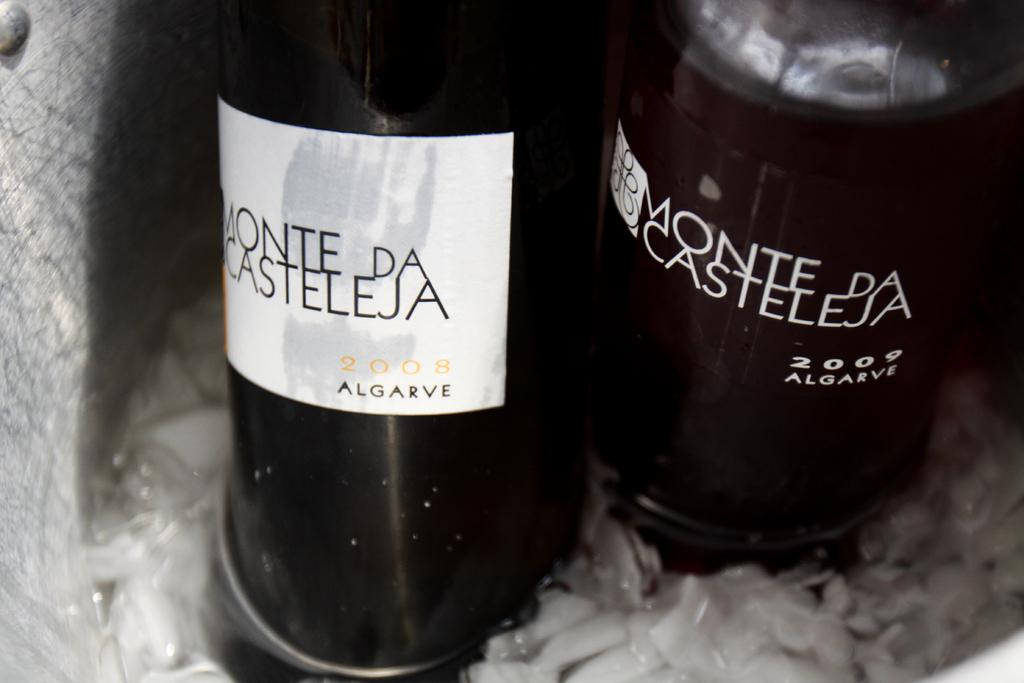<image>
Describe the image concisely. the word monte that is on the back of a bottle 